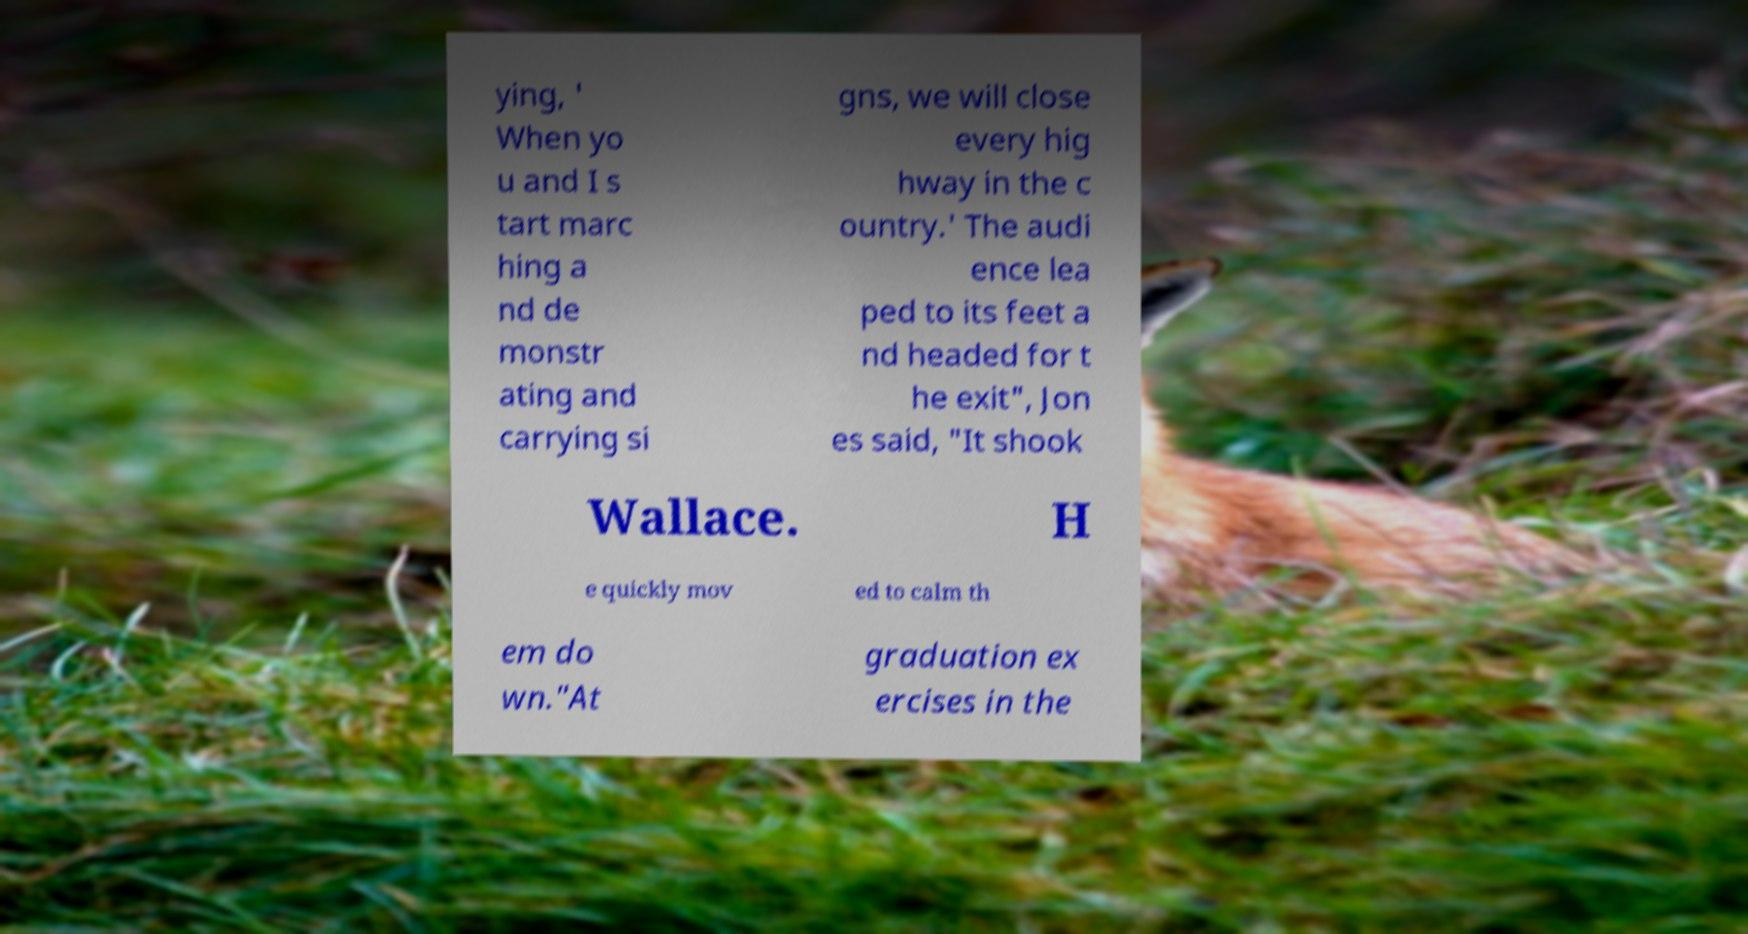Please identify and transcribe the text found in this image. ying, ' When yo u and I s tart marc hing a nd de monstr ating and carrying si gns, we will close every hig hway in the c ountry.' The audi ence lea ped to its feet a nd headed for t he exit", Jon es said, "It shook Wallace. H e quickly mov ed to calm th em do wn."At graduation ex ercises in the 